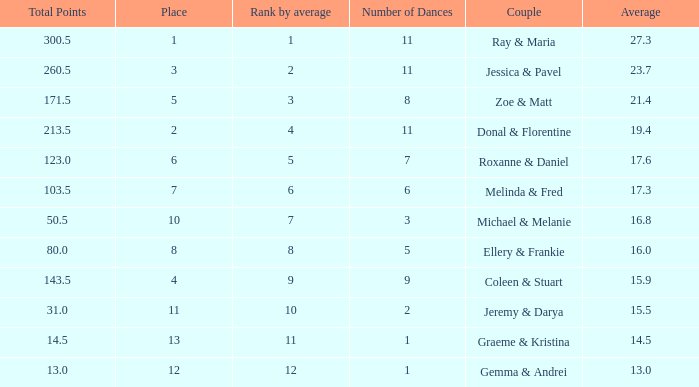What is the couples name where the average is 15.9? Coleen & Stuart. Can you give me this table as a dict? {'header': ['Total Points', 'Place', 'Rank by average', 'Number of Dances', 'Couple', 'Average'], 'rows': [['300.5', '1', '1', '11', 'Ray & Maria', '27.3'], ['260.5', '3', '2', '11', 'Jessica & Pavel', '23.7'], ['171.5', '5', '3', '8', 'Zoe & Matt', '21.4'], ['213.5', '2', '4', '11', 'Donal & Florentine', '19.4'], ['123.0', '6', '5', '7', 'Roxanne & Daniel', '17.6'], ['103.5', '7', '6', '6', 'Melinda & Fred', '17.3'], ['50.5', '10', '7', '3', 'Michael & Melanie', '16.8'], ['80.0', '8', '8', '5', 'Ellery & Frankie', '16.0'], ['143.5', '4', '9', '9', 'Coleen & Stuart', '15.9'], ['31.0', '11', '10', '2', 'Jeremy & Darya', '15.5'], ['14.5', '13', '11', '1', 'Graeme & Kristina', '14.5'], ['13.0', '12', '12', '1', 'Gemma & Andrei', '13.0']]} 